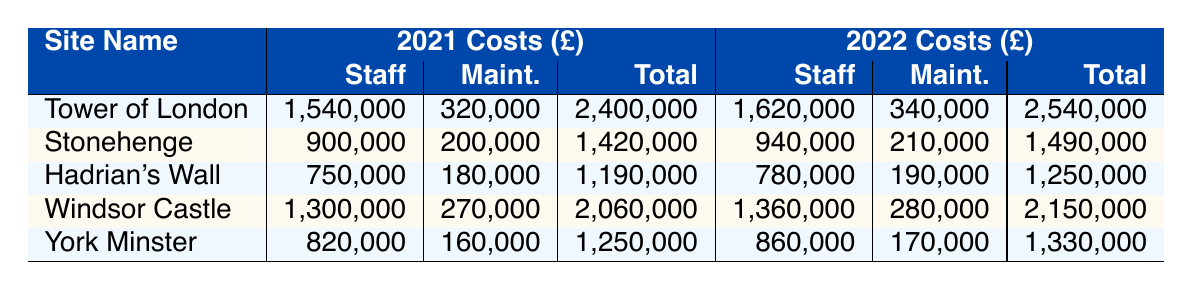What were the total operational costs for the Tower of London in 2021? The table shows that the Total Costs for the Tower of London in 2021 were £2,400,000.
Answer: £2,400,000 How much did the security costs increase for Stonehenge from 2021 to 2022? In 2021, the Security costs for Stonehenge were £100,000 and in 2022, they were £105,000. The increase is £105,000 - £100,000 = £5,000.
Answer: £5,000 Which historic site had the highest staff salaries in 2022? According to the table, the Windsor Castle had the highest staff salaries in 2022 at £1,360,000.
Answer: Windsor Castle Did York Minster's total operational costs decrease from 2021 to 2022? In the table, York Minster’s Total Costs in 2021 were £1,250,000, and in 2022 it was £1,330,000. Since £1,330,000 is higher, the costs did not decrease.
Answer: No What is the average maintenance cost for all sites in 2021? The maintenance costs for all sites in 2021 are as follows: Tower of London (£320,000), Stonehenge (£200,000), Hadrian’s Wall (£180,000), Windsor Castle (£270,000), and York Minster (£160,000). The total maintenance cost is £320,000 + £200,000 + £180,000 + £270,000 + £160,000 = £1,130,000. There are 5 sites, so the average is £1,130,000 / 5 = £226,000.
Answer: £226,000 By how much did the total operational costs of Hadrian's Wall change from 2021 to 2022? In 2021, Hadrian's Wall had total costs of £1,190,000, and in 2022 they were £1,250,000. The difference is £1,250,000 - £1,190,000 = £60,000.
Answer: £60,000 